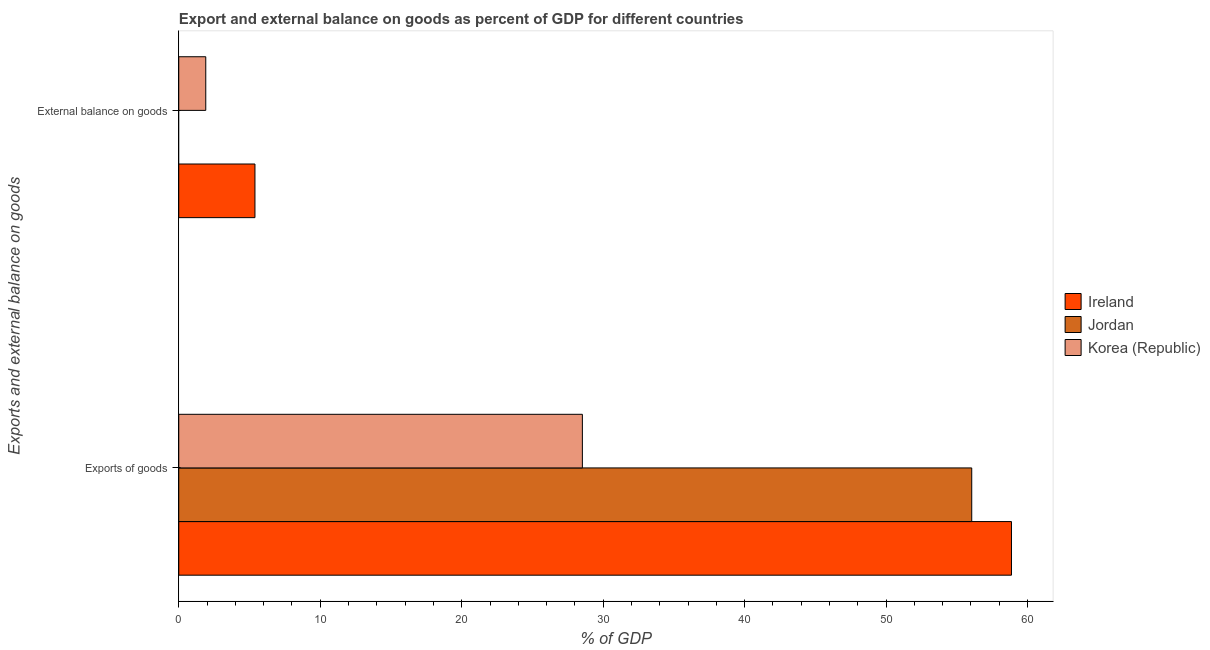How many different coloured bars are there?
Provide a succinct answer. 3. How many groups of bars are there?
Offer a terse response. 2. Are the number of bars per tick equal to the number of legend labels?
Ensure brevity in your answer.  No. Are the number of bars on each tick of the Y-axis equal?
Your answer should be compact. No. How many bars are there on the 1st tick from the bottom?
Give a very brief answer. 3. What is the label of the 1st group of bars from the top?
Your answer should be compact. External balance on goods. What is the external balance on goods as percentage of gdp in Korea (Republic)?
Keep it short and to the point. 1.91. Across all countries, what is the maximum external balance on goods as percentage of gdp?
Provide a short and direct response. 5.39. Across all countries, what is the minimum export of goods as percentage of gdp?
Provide a succinct answer. 28.53. In which country was the export of goods as percentage of gdp maximum?
Provide a succinct answer. Ireland. What is the total external balance on goods as percentage of gdp in the graph?
Your answer should be very brief. 7.29. What is the difference between the export of goods as percentage of gdp in Jordan and that in Ireland?
Offer a terse response. -2.81. What is the difference between the external balance on goods as percentage of gdp in Ireland and the export of goods as percentage of gdp in Korea (Republic)?
Provide a succinct answer. -23.15. What is the average external balance on goods as percentage of gdp per country?
Provide a short and direct response. 2.43. What is the difference between the external balance on goods as percentage of gdp and export of goods as percentage of gdp in Ireland?
Your answer should be very brief. -53.48. In how many countries, is the external balance on goods as percentage of gdp greater than 10 %?
Offer a very short reply. 0. What is the ratio of the export of goods as percentage of gdp in Korea (Republic) to that in Ireland?
Provide a short and direct response. 0.48. Is the export of goods as percentage of gdp in Korea (Republic) less than that in Ireland?
Make the answer very short. Yes. In how many countries, is the external balance on goods as percentage of gdp greater than the average external balance on goods as percentage of gdp taken over all countries?
Keep it short and to the point. 1. How many bars are there?
Provide a short and direct response. 5. How many countries are there in the graph?
Ensure brevity in your answer.  3. Does the graph contain any zero values?
Your answer should be very brief. Yes. Where does the legend appear in the graph?
Give a very brief answer. Center right. How are the legend labels stacked?
Make the answer very short. Vertical. What is the title of the graph?
Offer a very short reply. Export and external balance on goods as percent of GDP for different countries. What is the label or title of the X-axis?
Offer a very short reply. % of GDP. What is the label or title of the Y-axis?
Your answer should be compact. Exports and external balance on goods. What is the % of GDP of Ireland in Exports of goods?
Ensure brevity in your answer.  58.86. What is the % of GDP in Jordan in Exports of goods?
Your answer should be compact. 56.05. What is the % of GDP in Korea (Republic) in Exports of goods?
Give a very brief answer. 28.53. What is the % of GDP in Ireland in External balance on goods?
Provide a short and direct response. 5.39. What is the % of GDP of Jordan in External balance on goods?
Your response must be concise. 0. What is the % of GDP in Korea (Republic) in External balance on goods?
Keep it short and to the point. 1.91. Across all Exports and external balance on goods, what is the maximum % of GDP in Ireland?
Ensure brevity in your answer.  58.86. Across all Exports and external balance on goods, what is the maximum % of GDP in Jordan?
Provide a succinct answer. 56.05. Across all Exports and external balance on goods, what is the maximum % of GDP in Korea (Republic)?
Make the answer very short. 28.53. Across all Exports and external balance on goods, what is the minimum % of GDP in Ireland?
Your response must be concise. 5.39. Across all Exports and external balance on goods, what is the minimum % of GDP of Korea (Republic)?
Your answer should be compact. 1.91. What is the total % of GDP of Ireland in the graph?
Provide a short and direct response. 64.25. What is the total % of GDP of Jordan in the graph?
Your answer should be compact. 56.05. What is the total % of GDP in Korea (Republic) in the graph?
Offer a very short reply. 30.44. What is the difference between the % of GDP of Ireland in Exports of goods and that in External balance on goods?
Your answer should be very brief. 53.48. What is the difference between the % of GDP of Korea (Republic) in Exports of goods and that in External balance on goods?
Give a very brief answer. 26.62. What is the difference between the % of GDP in Ireland in Exports of goods and the % of GDP in Korea (Republic) in External balance on goods?
Give a very brief answer. 56.95. What is the difference between the % of GDP of Jordan in Exports of goods and the % of GDP of Korea (Republic) in External balance on goods?
Provide a short and direct response. 54.15. What is the average % of GDP of Ireland per Exports and external balance on goods?
Provide a short and direct response. 32.12. What is the average % of GDP of Jordan per Exports and external balance on goods?
Make the answer very short. 28.03. What is the average % of GDP of Korea (Republic) per Exports and external balance on goods?
Your answer should be compact. 15.22. What is the difference between the % of GDP of Ireland and % of GDP of Jordan in Exports of goods?
Provide a short and direct response. 2.81. What is the difference between the % of GDP of Ireland and % of GDP of Korea (Republic) in Exports of goods?
Ensure brevity in your answer.  30.33. What is the difference between the % of GDP of Jordan and % of GDP of Korea (Republic) in Exports of goods?
Your answer should be compact. 27.52. What is the difference between the % of GDP of Ireland and % of GDP of Korea (Republic) in External balance on goods?
Your response must be concise. 3.48. What is the ratio of the % of GDP in Ireland in Exports of goods to that in External balance on goods?
Provide a succinct answer. 10.93. What is the ratio of the % of GDP of Korea (Republic) in Exports of goods to that in External balance on goods?
Ensure brevity in your answer.  14.95. What is the difference between the highest and the second highest % of GDP of Ireland?
Offer a very short reply. 53.48. What is the difference between the highest and the second highest % of GDP in Korea (Republic)?
Your answer should be very brief. 26.62. What is the difference between the highest and the lowest % of GDP in Ireland?
Keep it short and to the point. 53.48. What is the difference between the highest and the lowest % of GDP in Jordan?
Give a very brief answer. 56.05. What is the difference between the highest and the lowest % of GDP of Korea (Republic)?
Ensure brevity in your answer.  26.62. 